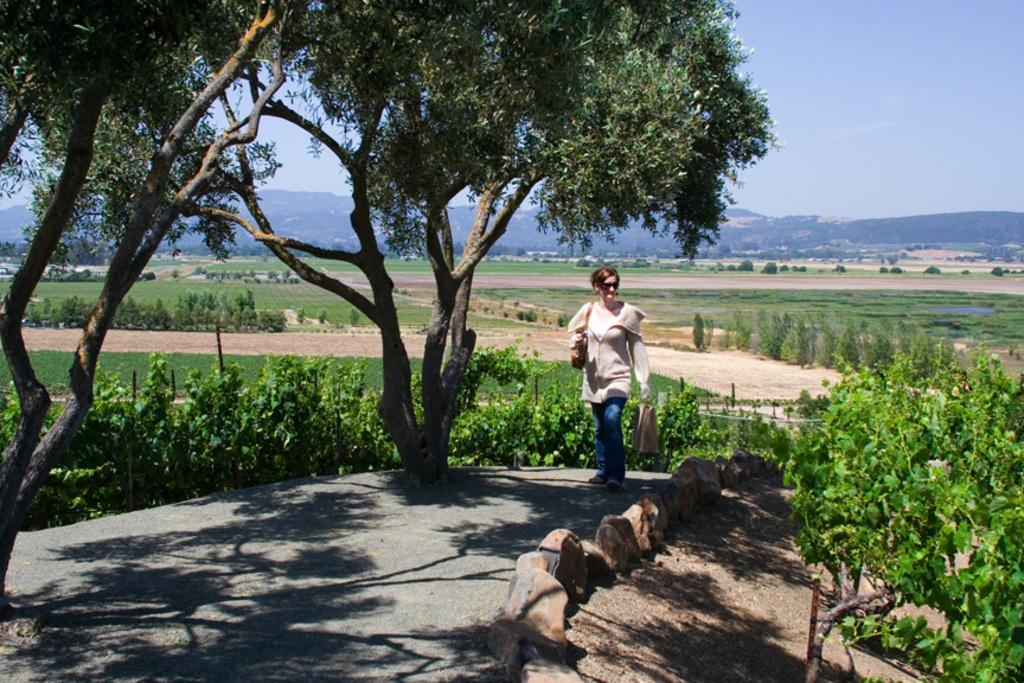Who is present in the image? There is a woman in the image. What is the natural environment like around the woman? There are trees around the woman. What other types of vegetation can be seen in the image? There are plants in the image. What type of agricultural activity is depicted in the image? There are crops in the image. What can be seen in the distance in the image? There are mountains in the background of the image. What type of pie is the woman holding in the image? There is no pie present in the image; the woman is not holding any object. 